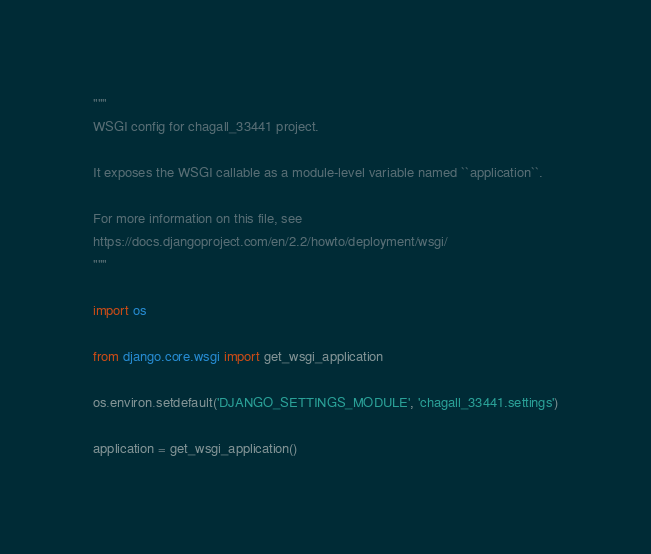<code> <loc_0><loc_0><loc_500><loc_500><_Python_>"""
WSGI config for chagall_33441 project.

It exposes the WSGI callable as a module-level variable named ``application``.

For more information on this file, see
https://docs.djangoproject.com/en/2.2/howto/deployment/wsgi/
"""

import os

from django.core.wsgi import get_wsgi_application

os.environ.setdefault('DJANGO_SETTINGS_MODULE', 'chagall_33441.settings')

application = get_wsgi_application()
</code> 